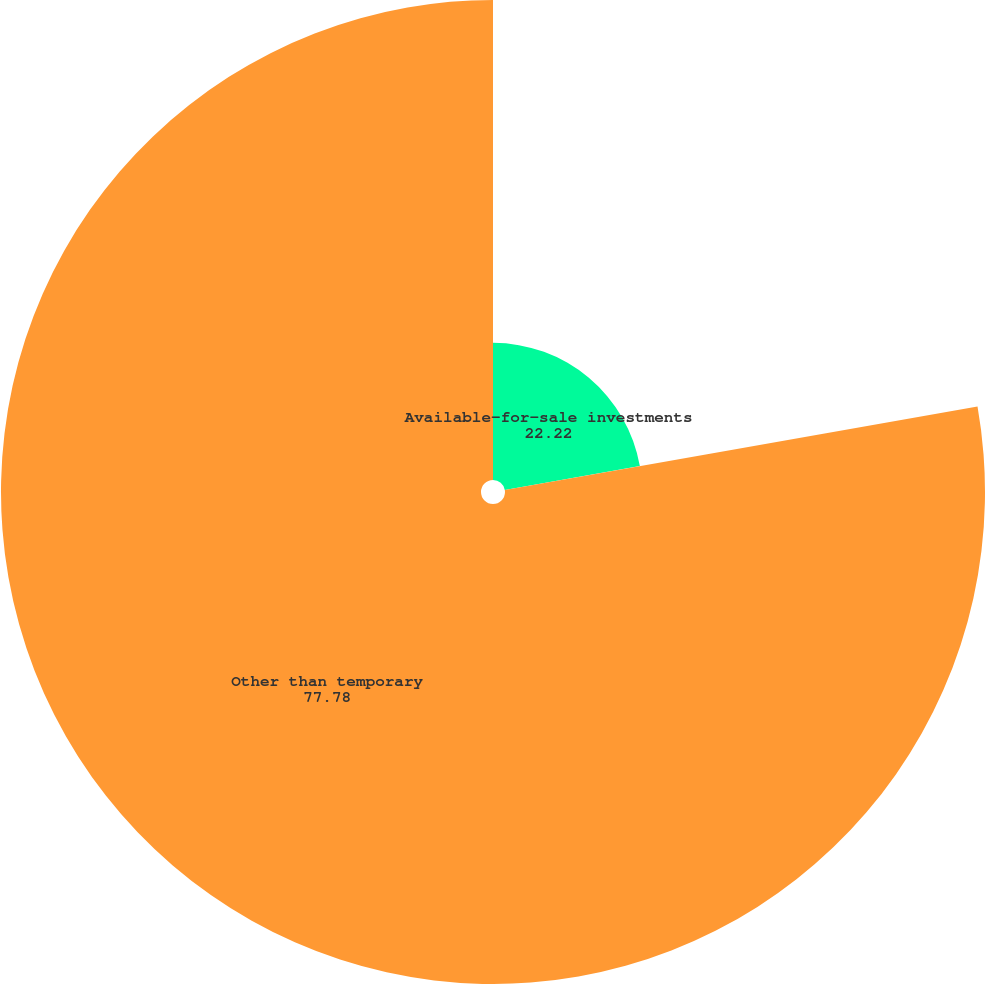<chart> <loc_0><loc_0><loc_500><loc_500><pie_chart><fcel>Available-for-sale investments<fcel>Other than temporary<nl><fcel>22.22%<fcel>77.78%<nl></chart> 